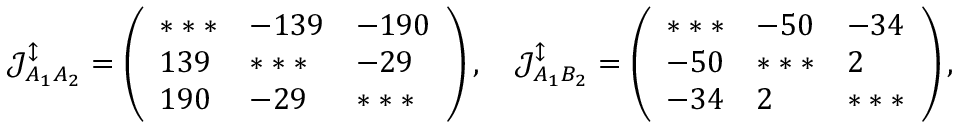Convert formula to latex. <formula><loc_0><loc_0><loc_500><loc_500>\mathcal { J } _ { A _ { 1 } A _ { 2 } } ^ { \updownarrow } = \left ( \begin{array} { l l l } { * * * } & { - 1 3 9 } & { - 1 9 0 } \\ { 1 3 9 } & { * * * } & { - 2 9 } \\ { 1 9 0 } & { - 2 9 } & { * * * } \end{array} \right ) , \quad \mathcal { J } _ { A _ { 1 } B _ { 2 } } ^ { \updownarrow } = \left ( \begin{array} { l l l } { * * * } & { - 5 0 } & { - 3 4 } \\ { - 5 0 } & { * * * } & { 2 } \\ { - 3 4 } & { 2 } & { * * * } \end{array} \right ) ,</formula> 